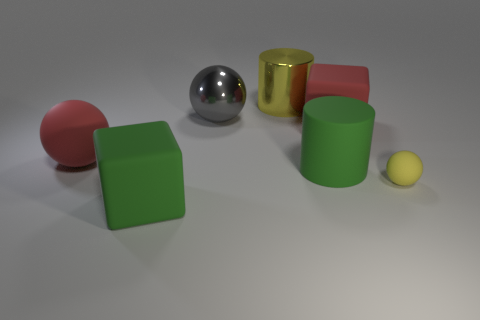Add 1 big matte spheres. How many objects exist? 8 Subtract all cylinders. How many objects are left? 5 Add 2 large matte cylinders. How many large matte cylinders are left? 3 Add 3 big blue rubber cylinders. How many big blue rubber cylinders exist? 3 Subtract 1 red blocks. How many objects are left? 6 Subtract all big matte cylinders. Subtract all gray metallic spheres. How many objects are left? 5 